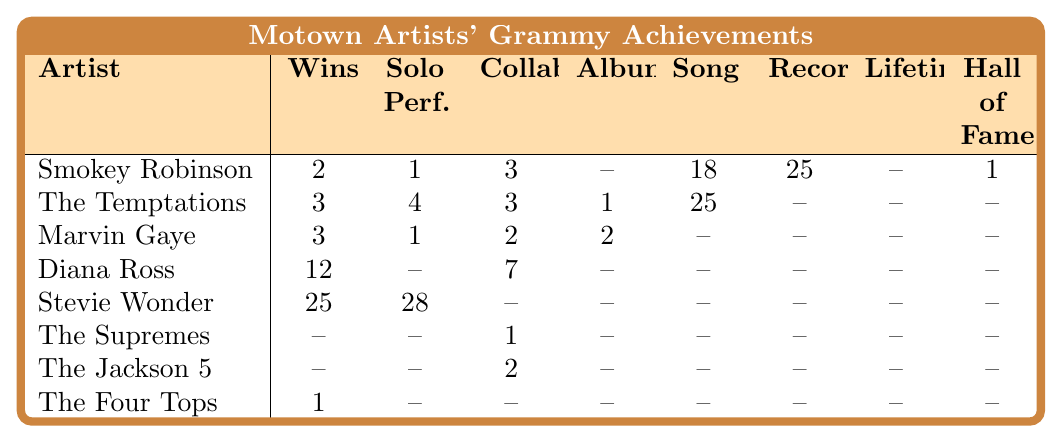What is the total number of Grammy wins by Smokey Robinson? Smokey Robinson's Grammy wins are listed in the table as 2.
Answer: 2 Who has the highest number of Grammy wins among the listed artists? The table shows Stevie Wonder with 25 Grammy wins, which is the highest among the artists listed.
Answer: Stevie Wonder How many Grammy nominations did The Temptations receive for solo performances? The table indicates The Temptations have 4 nominations for solo performances.
Answer: 4 Did The Supremes receive any Grammy wins? The table shows that The Supremes have no Grammy wins listed.
Answer: No How many total Grammy nominations for albums do Marvin Gaye, Diana Ross, and Stevie Wonder have? Marvin Gaye has 2, Diana Ross has 0, and Stevie Wonder has 0 for albums. The total is 2 + 0 + 0 = 2.
Answer: 2 Which artist has the most nominations for solo performances, and how many did they receive? The table indicates Stevie Wonder has 28 nominations for solo performances, which is the most.
Answer: Stevie Wonder, 28 If you combine the Grammy wins of Smokey Robinson and The Four Tops, what do you get? Smokey Robinson has 2 wins and The Four Tops have 1 win. Their combined total is 2 + 1 = 3.
Answer: 3 Is it true that Diana Ross received more nominations for collaboration than Marvin Gaye? Diana Ross has 0 nominations for collaboration and Marvin Gaye has 2, so it is false.
Answer: No What is the average number of Grammy wins for the artists listed in the table? The total number of wins is 2 + 3 + 3 + 12 + 25 + 1 + 0 + 0 = 46. There are 8 artists, so the average is 46/8 = 5.75.
Answer: 5.75 Among the artists listed, how many have received Grammy nominations for Hall of Fame? The table indicates only Smokey Robinson has received a nomination for Hall of Fame, with 1 nomination.
Answer: 1 